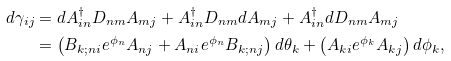<formula> <loc_0><loc_0><loc_500><loc_500>d \gamma _ { i j } & = d A ^ { \dagger } _ { i n } D _ { n m } A _ { m j } + A ^ { \dagger } _ { i n } D _ { n m } d A _ { m j } + A ^ { \dagger } _ { i n } d D _ { n m } A _ { m j } \\ & = \left ( B _ { k ; n i } e ^ { \phi _ { n } } A _ { n j } + A _ { n i } e ^ { \phi _ { n } } B _ { k ; n j } \right ) d \theta _ { k } + \left ( A _ { k i } e ^ { \phi _ { k } } A _ { k j } \right ) d \phi _ { k } , \\</formula> 